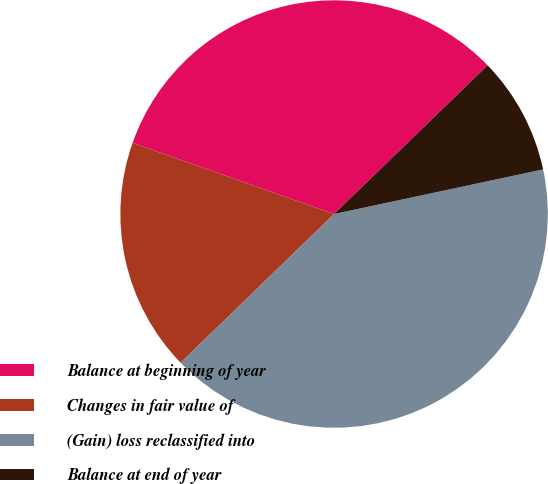Convert chart to OTSL. <chart><loc_0><loc_0><loc_500><loc_500><pie_chart><fcel>Balance at beginning of year<fcel>Changes in fair value of<fcel>(Gain) loss reclassified into<fcel>Balance at end of year<nl><fcel>32.35%<fcel>17.65%<fcel>41.1%<fcel>8.9%<nl></chart> 